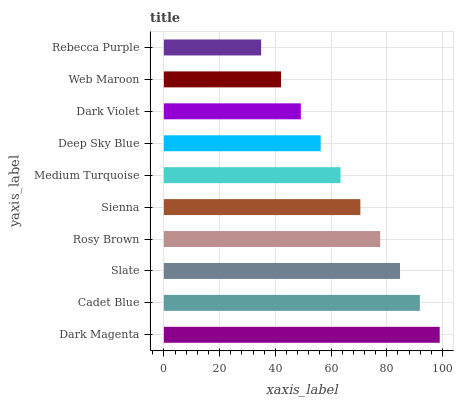Is Rebecca Purple the minimum?
Answer yes or no. Yes. Is Dark Magenta the maximum?
Answer yes or no. Yes. Is Cadet Blue the minimum?
Answer yes or no. No. Is Cadet Blue the maximum?
Answer yes or no. No. Is Dark Magenta greater than Cadet Blue?
Answer yes or no. Yes. Is Cadet Blue less than Dark Magenta?
Answer yes or no. Yes. Is Cadet Blue greater than Dark Magenta?
Answer yes or no. No. Is Dark Magenta less than Cadet Blue?
Answer yes or no. No. Is Sienna the high median?
Answer yes or no. Yes. Is Medium Turquoise the low median?
Answer yes or no. Yes. Is Slate the high median?
Answer yes or no. No. Is Dark Magenta the low median?
Answer yes or no. No. 